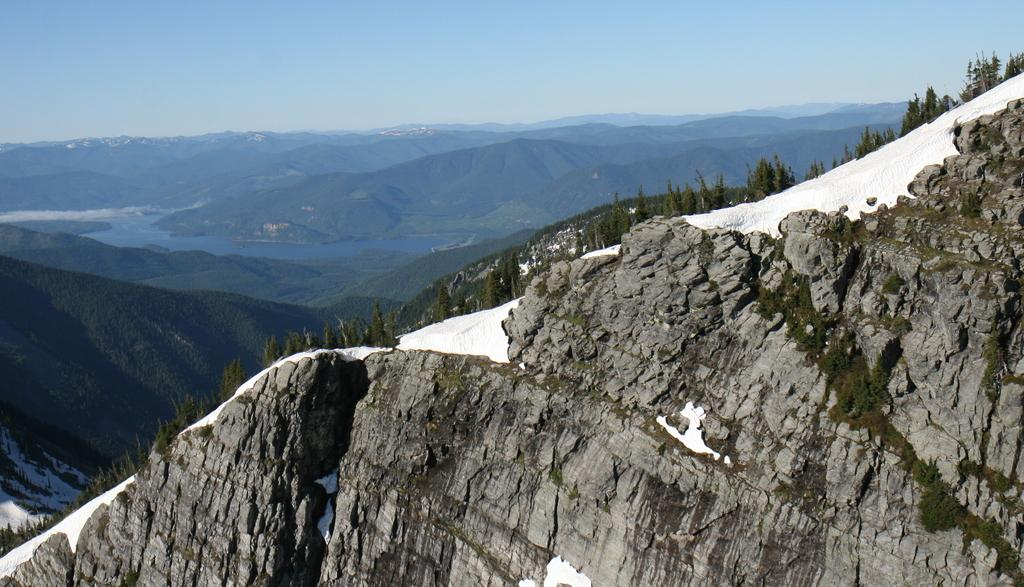What type of weather condition is depicted in the image? There is snow on the hill in the image, indicating a winter scene. What can be seen in the background of the image? There are trees and mountains in the background of the image. What is visible at the top of the image? The sky is visible in the background of the image. What type of flower is being taught to grow in the image? There is no flower or teaching activity present in the image. What type of steel structure can be seen in the image? There is no steel structure present in the image. 